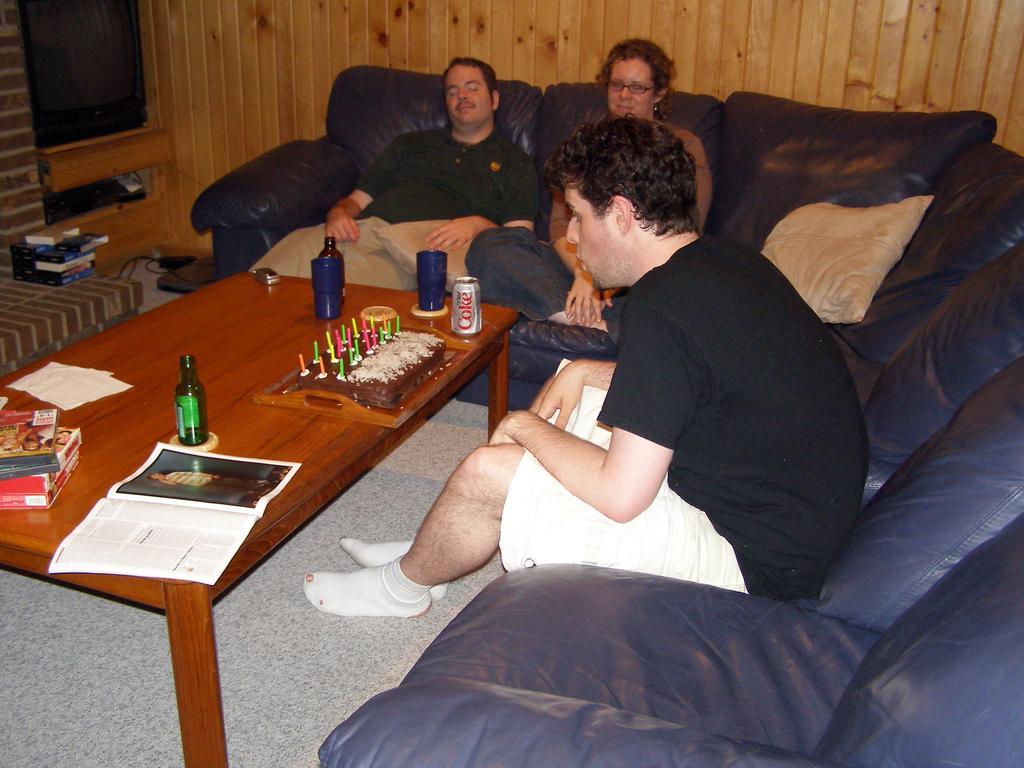How would you summarize this image in a sentence or two? In this picture we can see two men and a woman sitting on a sofa and in front of them on the table we can see bottles, tin, cake and in the background we can see a television, wall. 